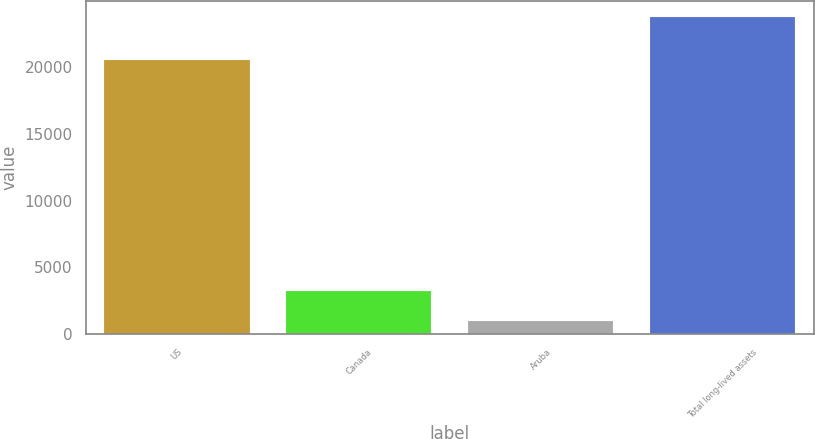<chart> <loc_0><loc_0><loc_500><loc_500><bar_chart><fcel>US<fcel>Canada<fcel>Aruba<fcel>Total long-lived assets<nl><fcel>20488<fcel>3260.6<fcel>981<fcel>23777<nl></chart> 